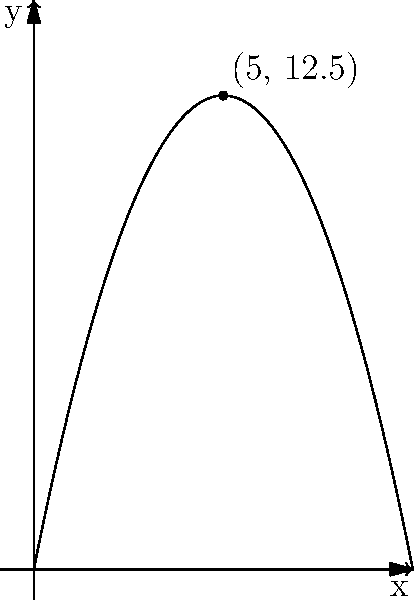During a Queen tribute show, a spotlight beam follows a parabolic trajectory represented by the function $f(x) = -0.5x^2 + 5x$, where $x$ is the horizontal distance from the stage (in meters) and $f(x)$ is the height of the beam (in meters). At what horizontal distance from the stage does the spotlight beam reach its maximum height, and what is this maximum height? To find the maximum height of the spotlight beam and its corresponding horizontal distance, we need to follow these steps:

1) The function given is $f(x) = -0.5x^2 + 5x$, which is a parabola.

2) For a parabola of the form $f(x) = ax^2 + bx + c$, the x-coordinate of the vertex is given by $x = -\frac{b}{2a}$.

3) In our case, $a = -0.5$ and $b = 5$. So:

   $x = -\frac{5}{2(-0.5)} = -\frac{5}{-1} = 5$ meters

4) To find the maximum height, we substitute this x-value back into the original function:

   $f(5) = -0.5(5)^2 + 5(5)$
         $= -0.5(25) + 25$
         $= -12.5 + 25$
         $= 12.5$ meters

Therefore, the spotlight beam reaches its maximum height of 12.5 meters at a horizontal distance of 5 meters from the stage.
Answer: 5 meters from stage; 12.5 meters high 